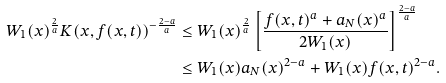Convert formula to latex. <formula><loc_0><loc_0><loc_500><loc_500>W _ { 1 } ( x ) ^ { \frac { 2 } { a } } K ( x , f ( x , t ) ) ^ { - \frac { 2 - a } { a } } & \leq W _ { 1 } ( x ) ^ { \frac { 2 } { a } } \left [ \frac { f ( x , t ) ^ { a } + a _ { N } ( x ) ^ { a } } { 2 W _ { 1 } ( x ) } \right ] ^ { \frac { 2 - a } { a } } \\ & \leq W _ { 1 } ( x ) a _ { N } ( x ) ^ { 2 - a } + W _ { 1 } ( x ) f ( x , t ) ^ { 2 - a } .</formula> 